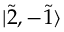Convert formula to latex. <formula><loc_0><loc_0><loc_500><loc_500>| \tilde { 2 } , - \tilde { 1 } \rangle</formula> 